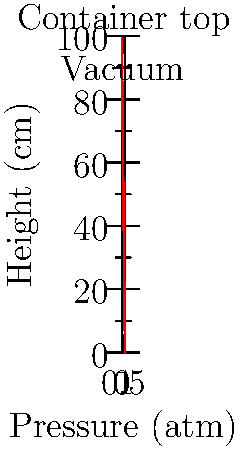You want to create a magical illusion where a small object appears to float inside a sealed transparent container. To achieve this effect, you need to create a partial vacuum at the top of the container. If the container is 100 cm tall and filled with air at 1 atm, what is the minimum pressure difference (in atm) between the bottom and top of the container required to make a small, light object appear to float near the top? To solve this problem, we'll follow these steps:

1. Understand the concept:
   - The object will appear to float when the upward force due to the pressure difference equals its weight.
   - We need to create a partial vacuum at the top of the container.

2. Use the hydrostatic pressure equation:
   $$ \Delta P = \rho g h $$
   Where:
   - $\Delta P$ is the pressure difference
   - $\rho$ is the density of air (approximately 1.225 kg/m³ at 1 atm)
   - $g$ is the acceleration due to gravity (9.81 m/s²)
   - $h$ is the height of the container (100 cm = 1 m)

3. Calculate the pressure difference:
   $$ \Delta P = 1.225 \text{ kg/m³} \times 9.81 \text{ m/s²} \times 1 \text{ m} $$
   $$ \Delta P = 12.02 \text{ Pa} $$

4. Convert the pressure difference to atmospheres:
   $$ \Delta P \text{ (in atm)} = \frac{12.02 \text{ Pa}}{101325 \text{ Pa/atm}} $$
   $$ \Delta P \approx 0.000119 \text{ atm} $$

5. Round to a reasonable precision for the illusion:
   A pressure difference of about 0.0001 atm or 0.01% of atmospheric pressure would be sufficient to create the illusion.
Answer: 0.0001 atm 